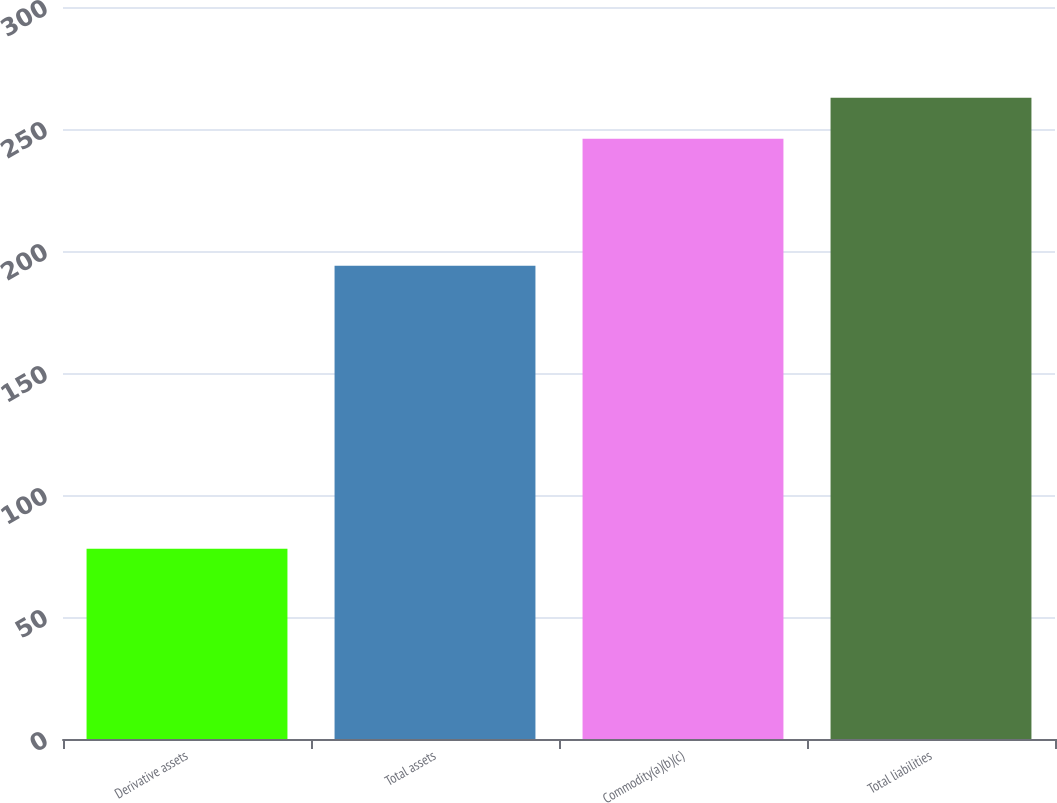Convert chart to OTSL. <chart><loc_0><loc_0><loc_500><loc_500><bar_chart><fcel>Derivative assets<fcel>Total assets<fcel>Commodity(a)(b)(c)<fcel>Total liabilities<nl><fcel>78<fcel>194<fcel>246<fcel>262.8<nl></chart> 